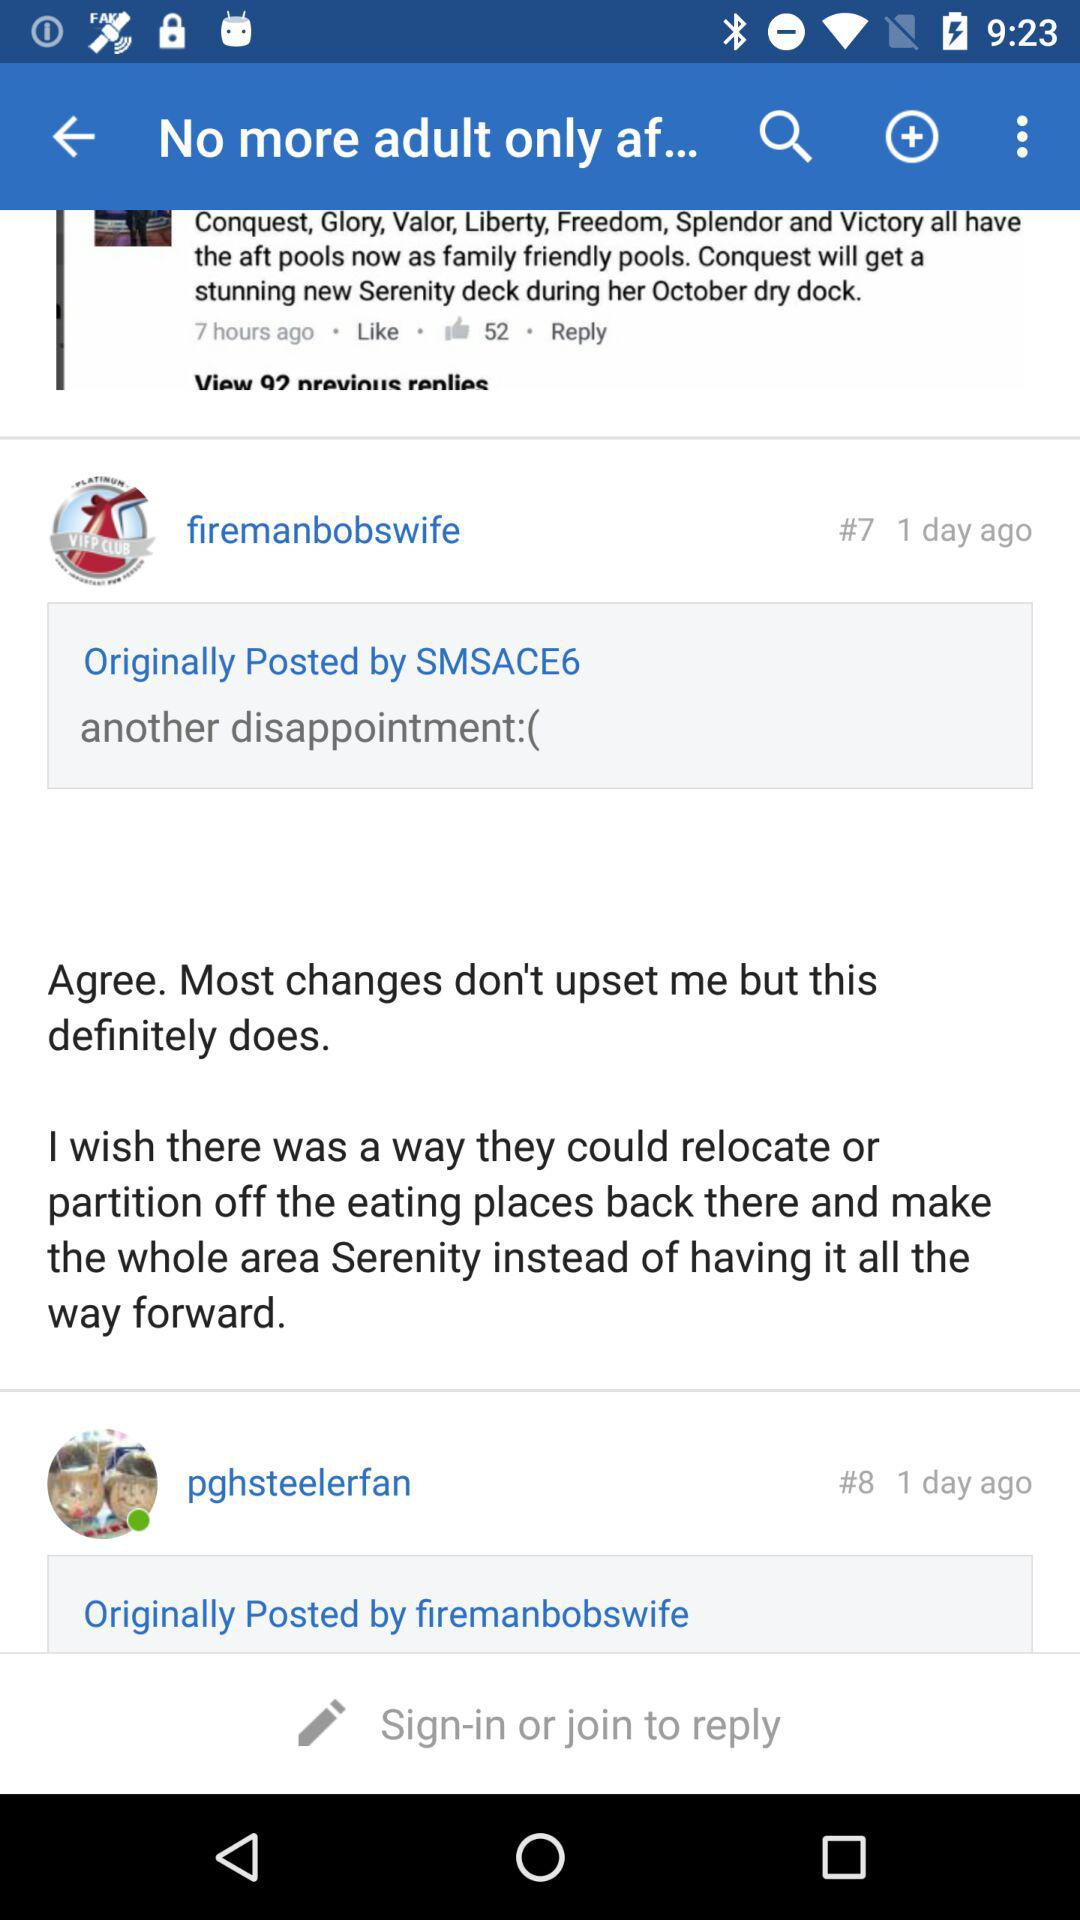How many replies are there to the first post?
Answer the question using a single word or phrase. 92 